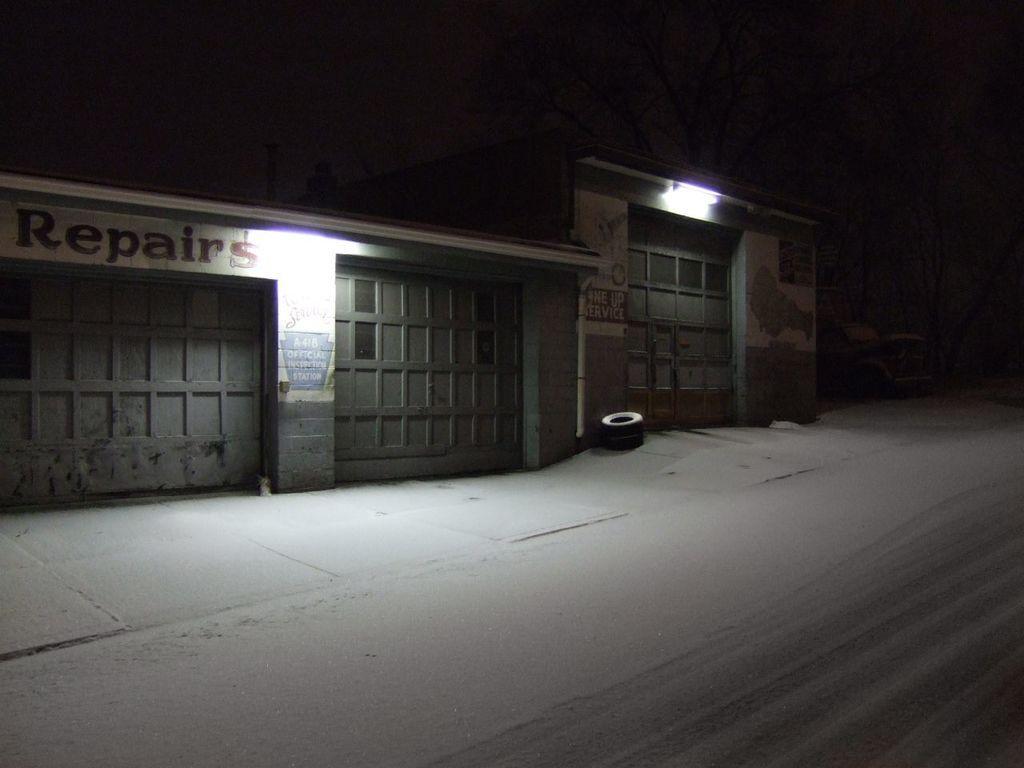Can you describe this image briefly? This image is taken during night time. In this image we can see buildings and tires and also trees. Image also consists of a vehicle and there is also a path for walking. 